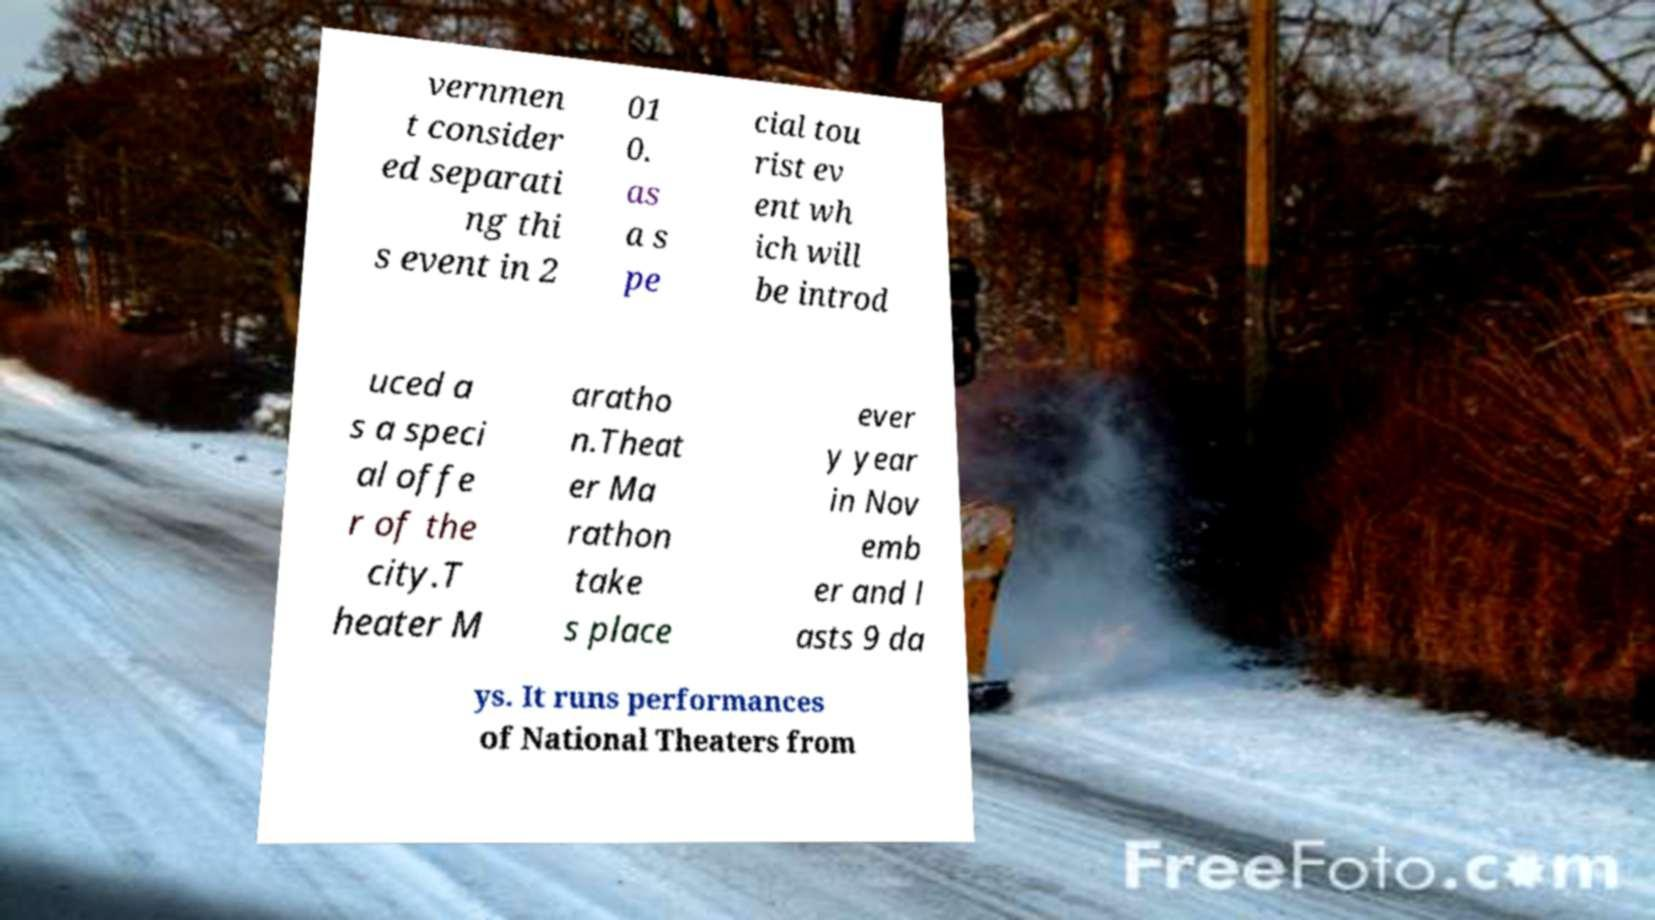I need the written content from this picture converted into text. Can you do that? vernmen t consider ed separati ng thi s event in 2 01 0. as a s pe cial tou rist ev ent wh ich will be introd uced a s a speci al offe r of the city.T heater M aratho n.Theat er Ma rathon take s place ever y year in Nov emb er and l asts 9 da ys. It runs performances of National Theaters from 